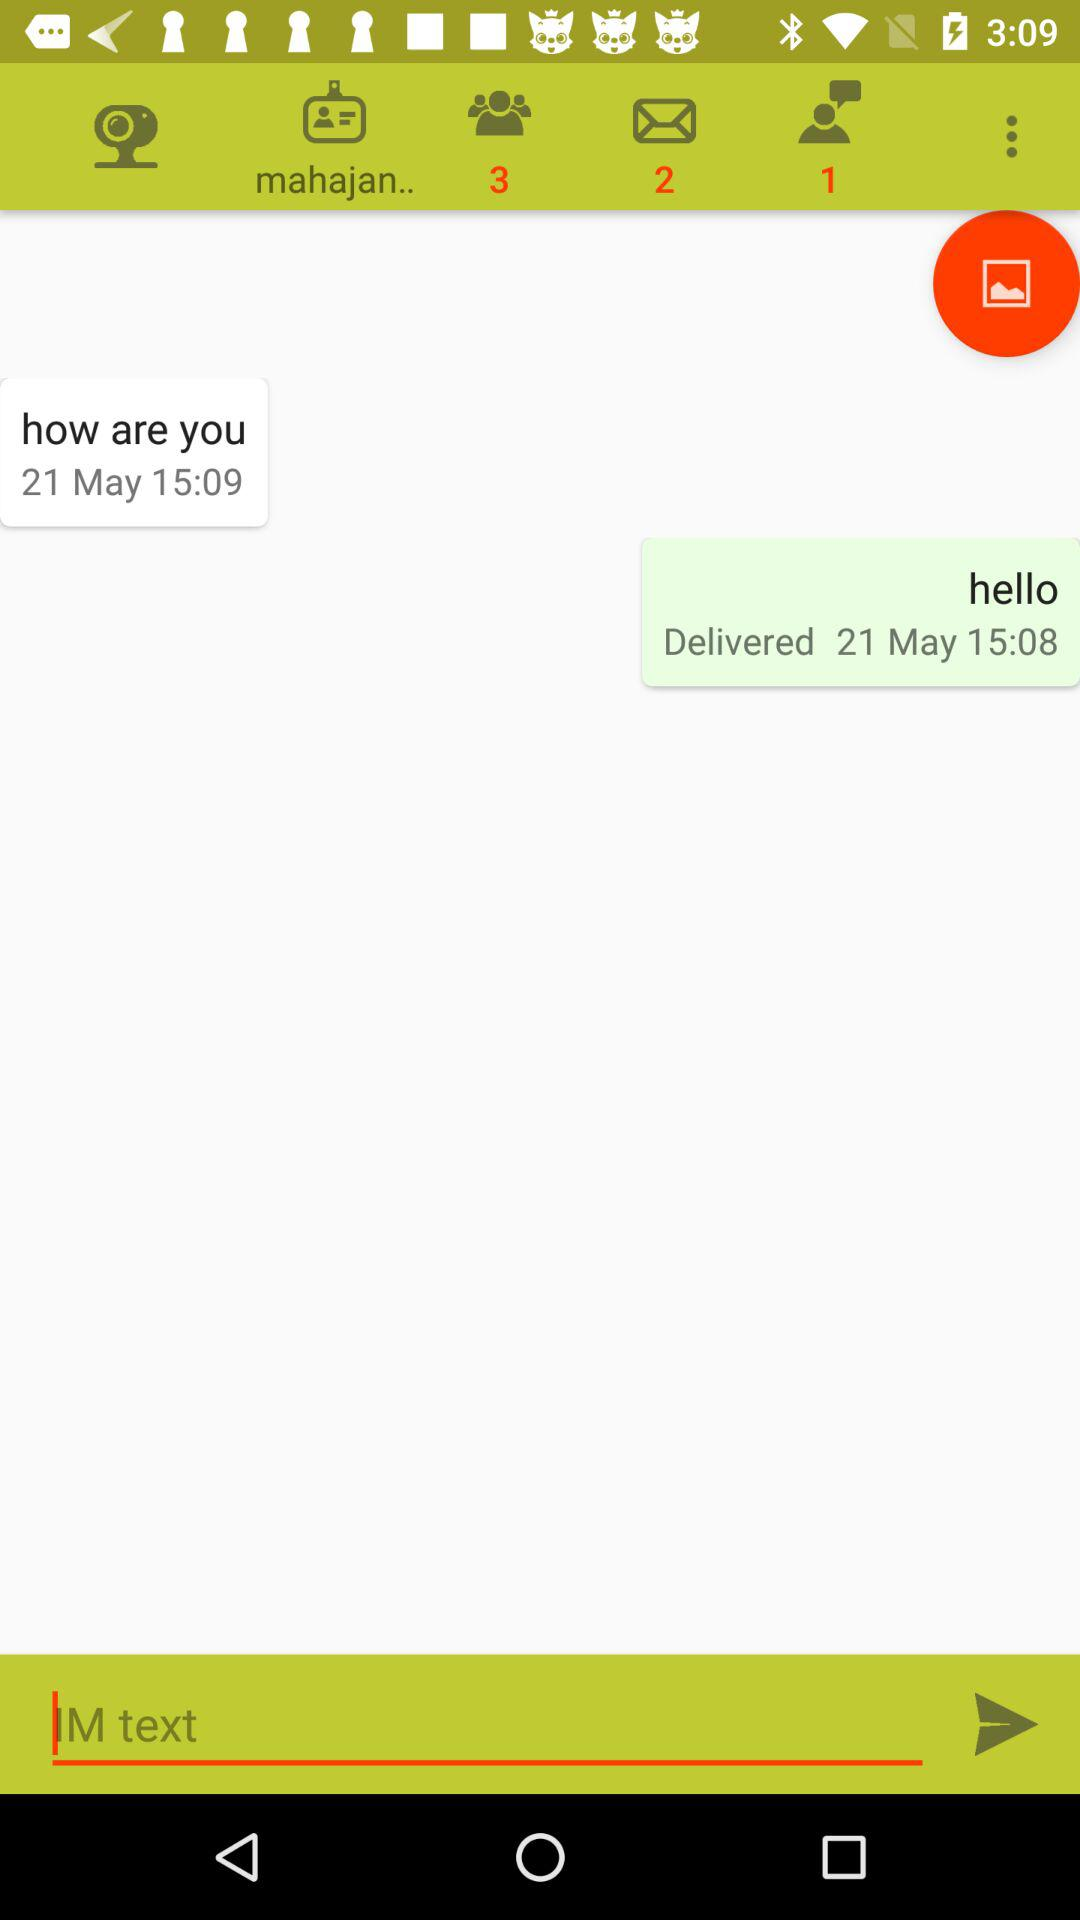How many unread messages are there? There are 2 unread messages. 